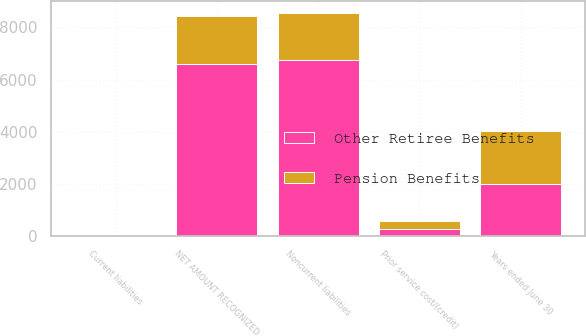Convert chart to OTSL. <chart><loc_0><loc_0><loc_500><loc_500><stacked_bar_chart><ecel><fcel>Years ended June 30<fcel>Current liabilities<fcel>Noncurrent liabilities<fcel>NET AMOUNT RECOGNIZED<fcel>Prior service cost/(credit)<nl><fcel>Other Retiree Benefits<fcel>2016<fcel>33<fcel>6761<fcel>6614<fcel>270<nl><fcel>Pension Benefits<fcel>2016<fcel>21<fcel>1808<fcel>1829<fcel>334<nl></chart> 